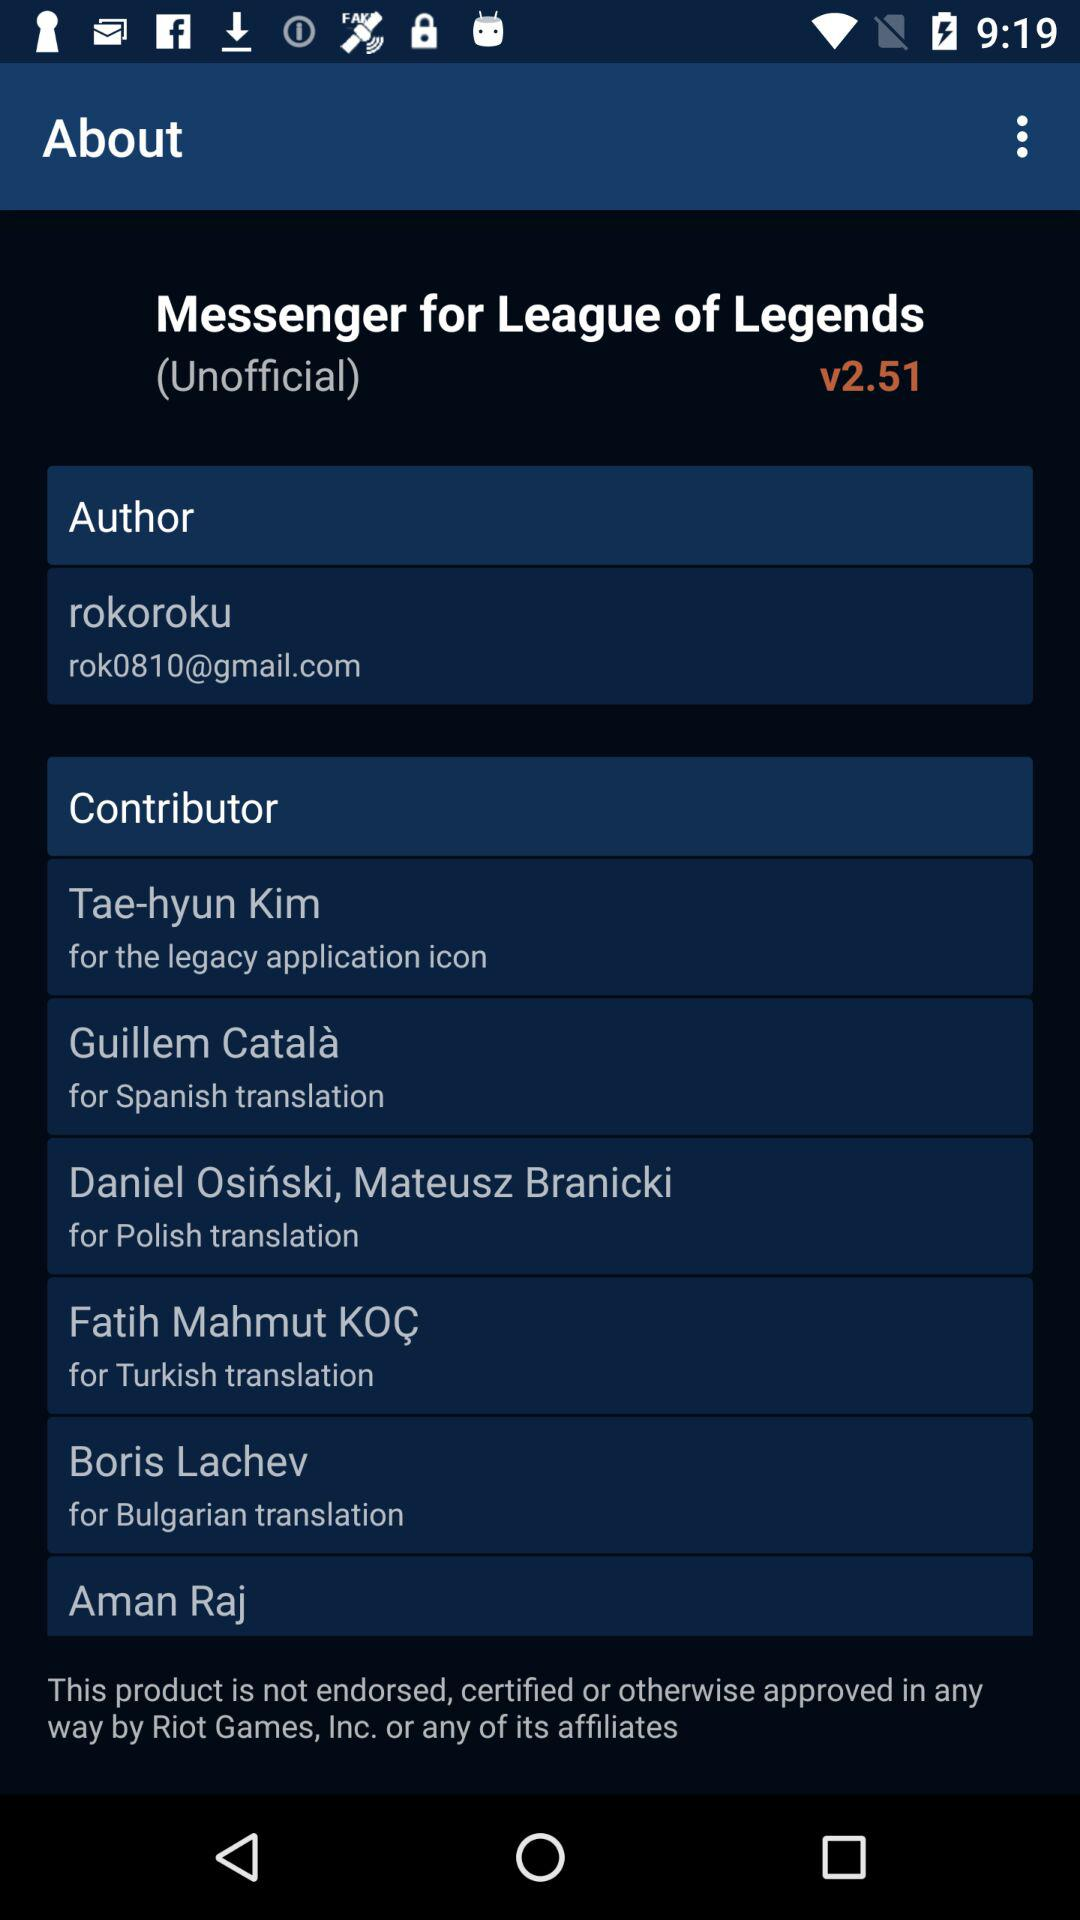What is the given author name? The author name is Rokoroku. 